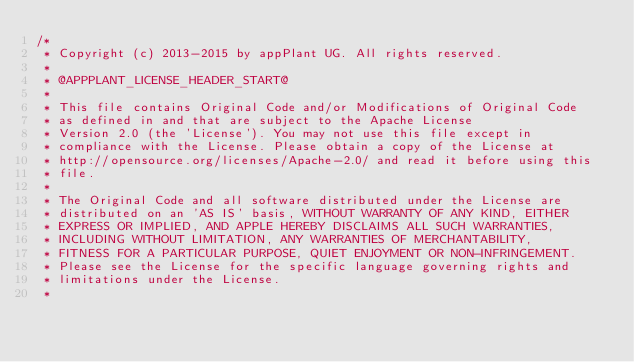Convert code to text. <code><loc_0><loc_0><loc_500><loc_500><_JavaScript_>/*
 * Copyright (c) 2013-2015 by appPlant UG. All rights reserved.
 *
 * @APPPLANT_LICENSE_HEADER_START@
 *
 * This file contains Original Code and/or Modifications of Original Code
 * as defined in and that are subject to the Apache License
 * Version 2.0 (the 'License'). You may not use this file except in
 * compliance with the License. Please obtain a copy of the License at
 * http://opensource.org/licenses/Apache-2.0/ and read it before using this
 * file.
 *
 * The Original Code and all software distributed under the License are
 * distributed on an 'AS IS' basis, WITHOUT WARRANTY OF ANY KIND, EITHER
 * EXPRESS OR IMPLIED, AND APPLE HEREBY DISCLAIMS ALL SUCH WARRANTIES,
 * INCLUDING WITHOUT LIMITATION, ANY WARRANTIES OF MERCHANTABILITY,
 * FITNESS FOR A PARTICULAR PURPOSE, QUIET ENJOYMENT OR NON-INFRINGEMENT.
 * Please see the License for the specific language governing rights and
 * limitations under the License.
 *</code> 